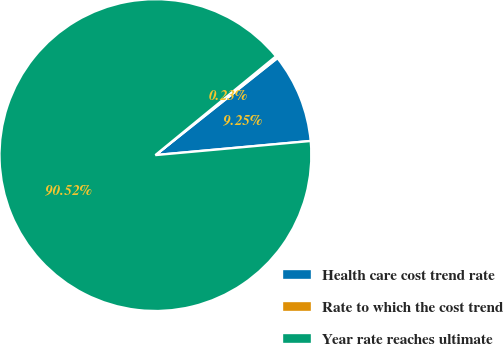Convert chart. <chart><loc_0><loc_0><loc_500><loc_500><pie_chart><fcel>Health care cost trend rate<fcel>Rate to which the cost trend<fcel>Year rate reaches ultimate<nl><fcel>9.25%<fcel>0.23%<fcel>90.52%<nl></chart> 